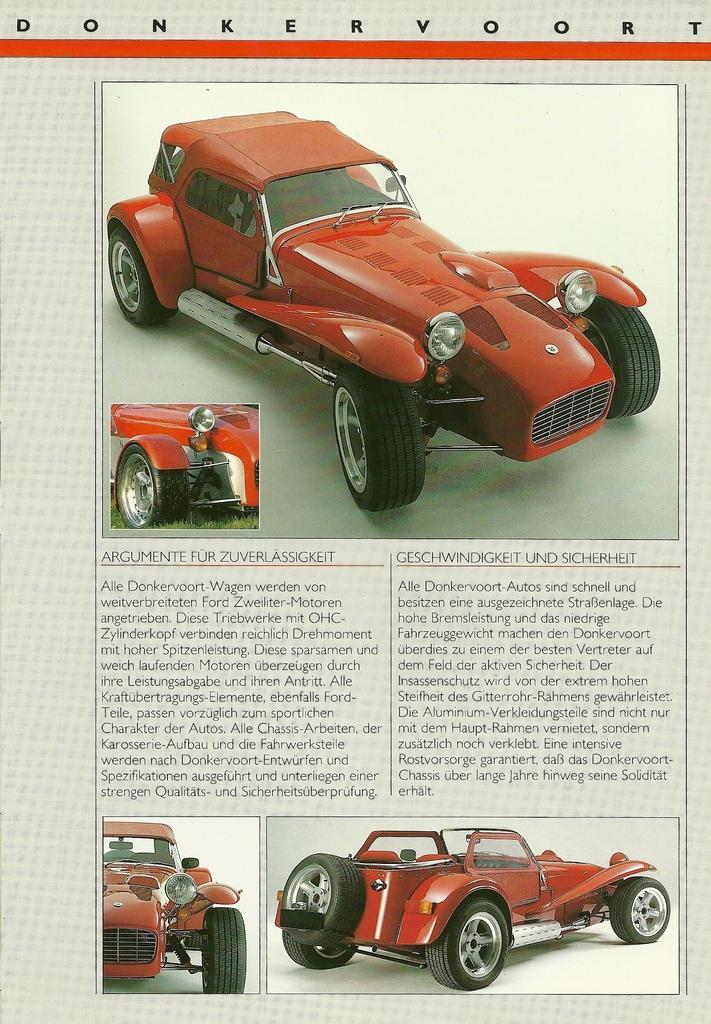Could you give a brief overview of what you see in this image? In this image there is paper and we can see pictures of a vehicle and there is text. 